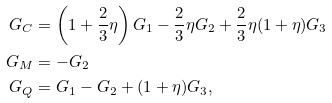Convert formula to latex. <formula><loc_0><loc_0><loc_500><loc_500>G _ { C } & = \left ( 1 + \frac { 2 } { 3 } \eta \right ) G _ { 1 } - \frac { 2 } { 3 } \eta G _ { 2 } + \frac { 2 } { 3 } \eta ( 1 + \eta ) G _ { 3 } \\ G _ { M } & = - G _ { 2 } \\ G _ { Q } & = G _ { 1 } - G _ { 2 } + ( 1 + \eta ) G _ { 3 } ,</formula> 